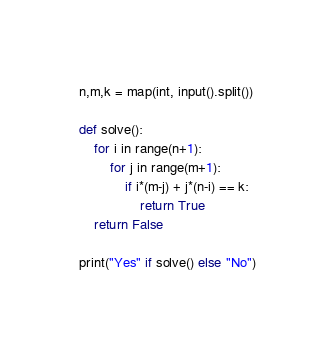Convert code to text. <code><loc_0><loc_0><loc_500><loc_500><_Python_>n,m,k = map(int, input().split())

def solve():
    for i in range(n+1):
        for j in range(m+1):
            if i*(m-j) + j*(n-i) == k:
                return True
    return False
                
print("Yes" if solve() else "No")
</code> 